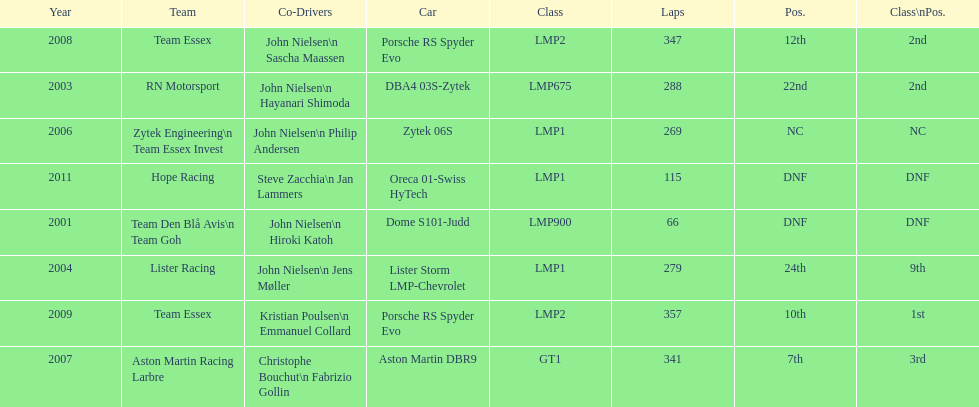What is the amount races that were competed in? 8. 